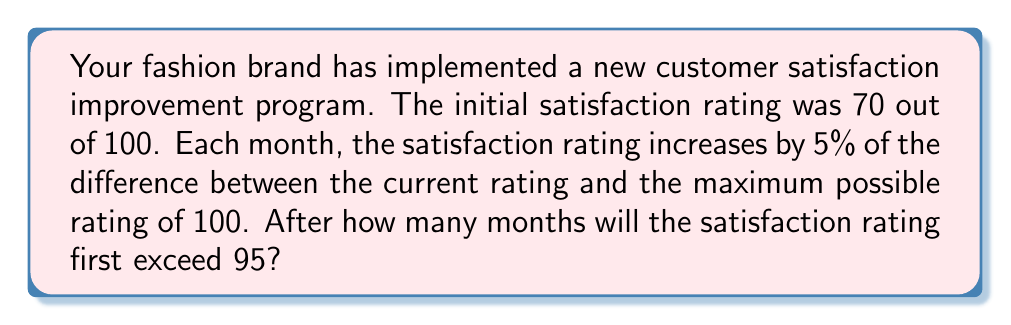Solve this math problem. Let's approach this step-by-step:

1) Let $a_n$ be the satisfaction rating after $n$ months. We're given that $a_0 = 70$.

2) The monthly increase is 5% of the difference between 100 and the current rating. This can be expressed as:

   $a_{n+1} = a_n + 0.05(100 - a_n)$

3) Simplifying this equation:

   $a_{n+1} = a_n + 5 - 0.05a_n = 0.95a_n + 5$

4) This is a first-order linear recurrence relation. The general solution is:

   $a_n = 100 - 30 \cdot 0.95^n$

5) We need to find the smallest $n$ for which $a_n > 95$. Let's set up the inequality:

   $100 - 30 \cdot 0.95^n > 95$

6) Solving for $0.95^n$:

   $-30 \cdot 0.95^n > -5$
   $0.95^n < \frac{1}{6}$

7) Taking logarithms of both sides:

   $n \log 0.95 < \log \frac{1}{6}$

   $n > \frac{\log \frac{1}{6}}{\log 0.95} \approx 31.86$

8) Since $n$ must be a whole number, the smallest $n$ that satisfies the inequality is 32.
Answer: 32 months 